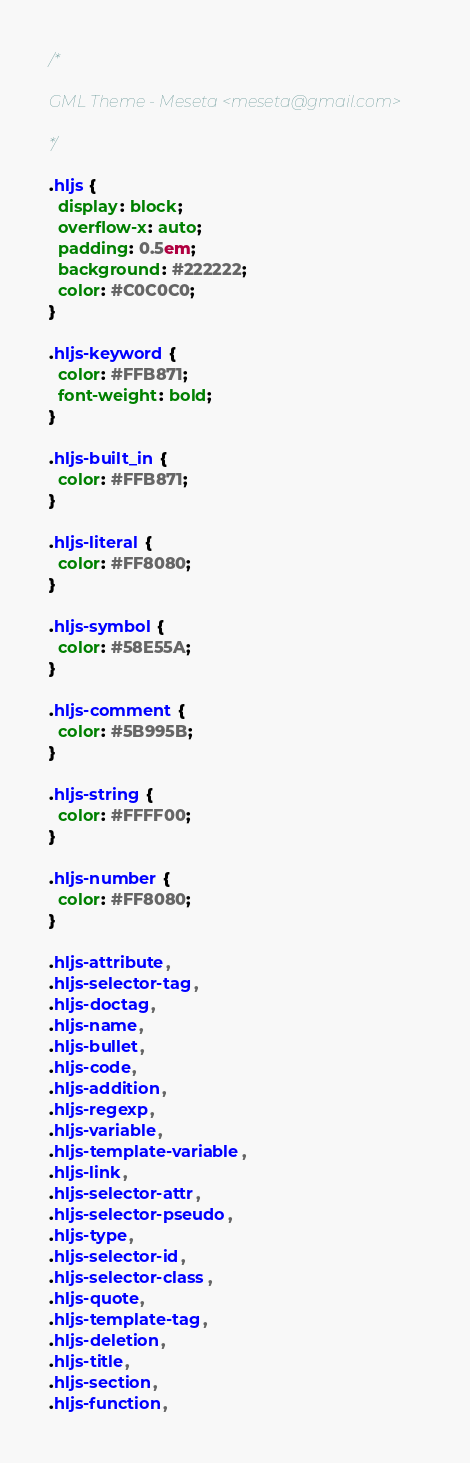<code> <loc_0><loc_0><loc_500><loc_500><_CSS_>/*

GML Theme - Meseta <meseta@gmail.com>

*/

.hljs {
  display: block;
  overflow-x: auto;
  padding: 0.5em;
  background: #222222;
  color: #C0C0C0;
}

.hljs-keyword {
  color: #FFB871;
  font-weight: bold;
}

.hljs-built_in {
  color: #FFB871;
}

.hljs-literal {
  color: #FF8080;
}

.hljs-symbol {
  color: #58E55A;
}

.hljs-comment {
  color: #5B995B;
}

.hljs-string {
  color: #FFFF00;
}

.hljs-number {
  color: #FF8080;
}

.hljs-attribute,
.hljs-selector-tag,
.hljs-doctag,
.hljs-name,
.hljs-bullet,
.hljs-code,
.hljs-addition,
.hljs-regexp,
.hljs-variable,
.hljs-template-variable,
.hljs-link,
.hljs-selector-attr,
.hljs-selector-pseudo,
.hljs-type,
.hljs-selector-id,
.hljs-selector-class,
.hljs-quote,
.hljs-template-tag,
.hljs-deletion,
.hljs-title,
.hljs-section,
.hljs-function,</code> 